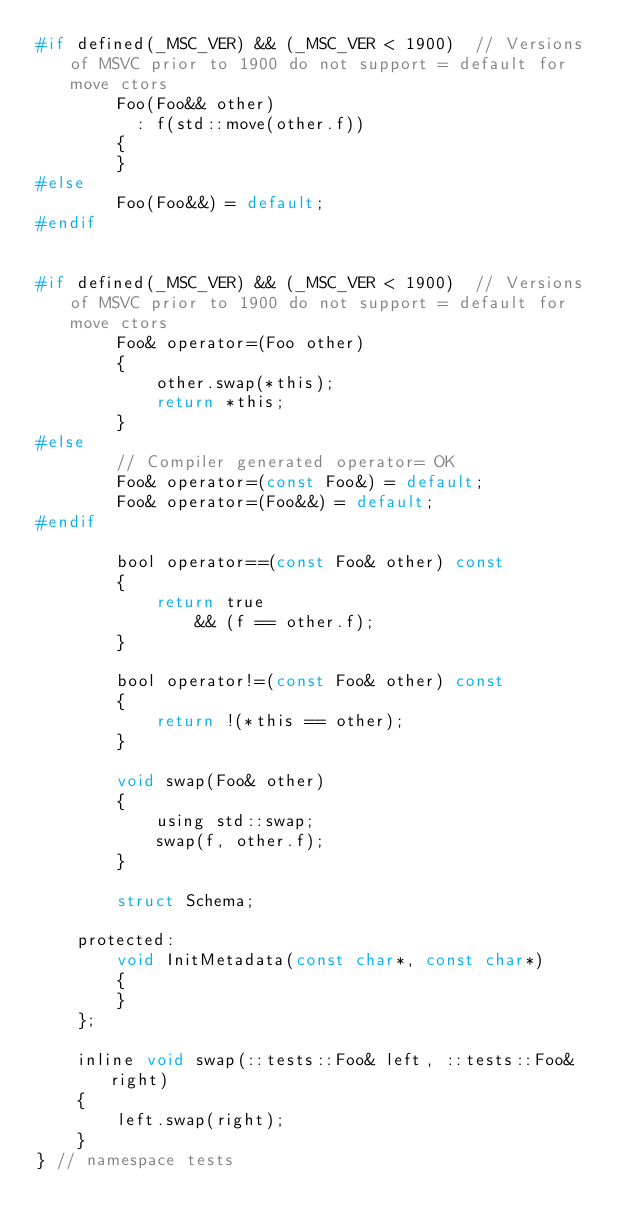<code> <loc_0><loc_0><loc_500><loc_500><_C_>#if defined(_MSC_VER) && (_MSC_VER < 1900)  // Versions of MSVC prior to 1900 do not support = default for move ctors
        Foo(Foo&& other)
          : f(std::move(other.f))
        {
        }
#else
        Foo(Foo&&) = default;
#endif
        
        
#if defined(_MSC_VER) && (_MSC_VER < 1900)  // Versions of MSVC prior to 1900 do not support = default for move ctors
        Foo& operator=(Foo other)
        {
            other.swap(*this);
            return *this;
        }
#else
        // Compiler generated operator= OK
        Foo& operator=(const Foo&) = default;
        Foo& operator=(Foo&&) = default;
#endif

        bool operator==(const Foo& other) const
        {
            return true
                && (f == other.f);
        }

        bool operator!=(const Foo& other) const
        {
            return !(*this == other);
        }

        void swap(Foo& other)
        {
            using std::swap;
            swap(f, other.f);
        }

        struct Schema;

    protected:
        void InitMetadata(const char*, const char*)
        {
        }
    };

    inline void swap(::tests::Foo& left, ::tests::Foo& right)
    {
        left.swap(right);
    }
} // namespace tests

</code> 